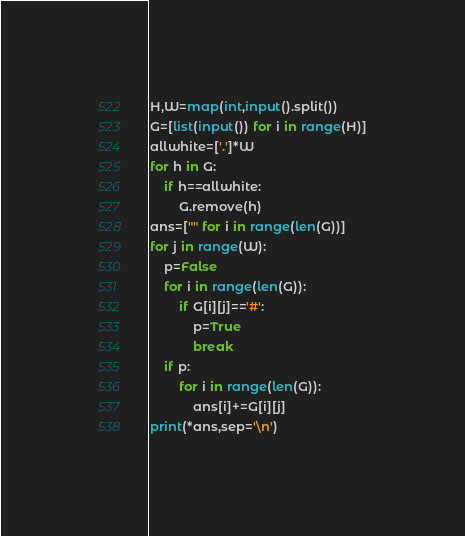Convert code to text. <code><loc_0><loc_0><loc_500><loc_500><_Python_>H,W=map(int,input().split())
G=[list(input()) for i in range(H)]
allwhite=['.']*W
for h in G:
    if h==allwhite:
        G.remove(h)
ans=["" for i in range(len(G))]
for j in range(W):
    p=False
    for i in range(len(G)):
        if G[i][j]=='#':
            p=True
            break
    if p:
        for i in range(len(G)):
            ans[i]+=G[i][j]
print(*ans,sep='\n')
</code> 